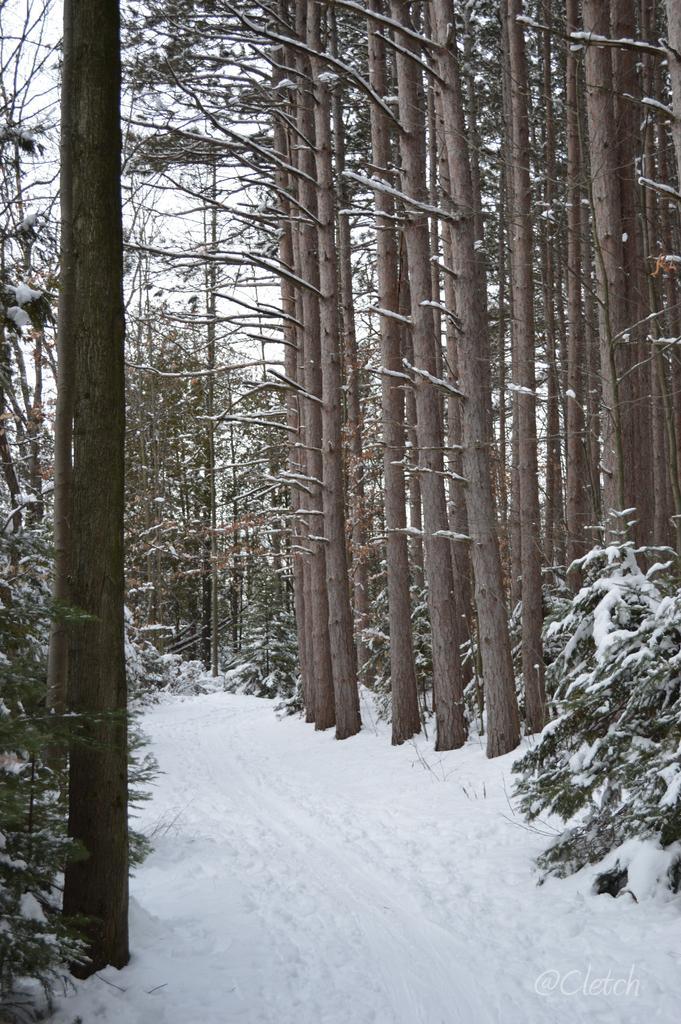Please provide a concise description of this image. Here there are trees, this is now, this is sky. 